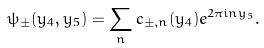Convert formula to latex. <formula><loc_0><loc_0><loc_500><loc_500>\psi _ { \pm } ( y _ { 4 } , y _ { 5 } ) = \sum _ { n } c _ { \pm , n } ( y _ { 4 } ) e ^ { 2 \pi i n y _ { 5 } } .</formula> 